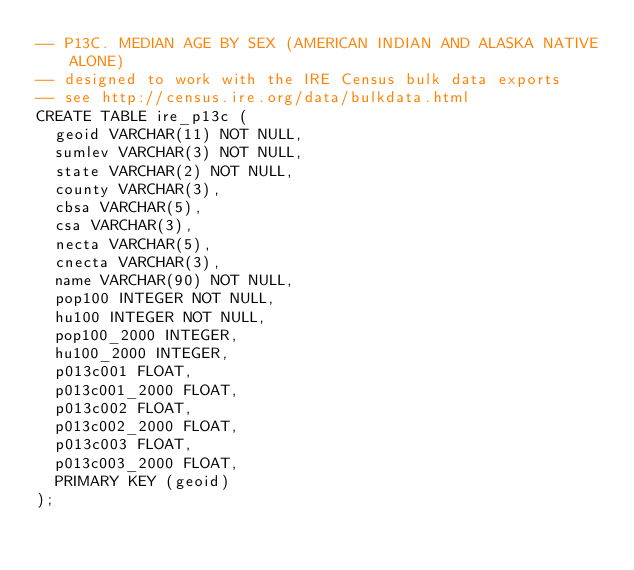<code> <loc_0><loc_0><loc_500><loc_500><_SQL_>-- P13C. MEDIAN AGE BY SEX (AMERICAN INDIAN AND ALASKA NATIVE ALONE)
-- designed to work with the IRE Census bulk data exports
-- see http://census.ire.org/data/bulkdata.html
CREATE TABLE ire_p13c (
	geoid VARCHAR(11) NOT NULL, 
	sumlev VARCHAR(3) NOT NULL, 
	state VARCHAR(2) NOT NULL, 
	county VARCHAR(3), 
	cbsa VARCHAR(5), 
	csa VARCHAR(3), 
	necta VARCHAR(5), 
	cnecta VARCHAR(3), 
	name VARCHAR(90) NOT NULL, 
	pop100 INTEGER NOT NULL, 
	hu100 INTEGER NOT NULL, 
	pop100_2000 INTEGER, 
	hu100_2000 INTEGER, 
	p013c001 FLOAT, 
	p013c001_2000 FLOAT, 
	p013c002 FLOAT, 
	p013c002_2000 FLOAT, 
	p013c003 FLOAT, 
	p013c003_2000 FLOAT, 
	PRIMARY KEY (geoid)
);
</code> 